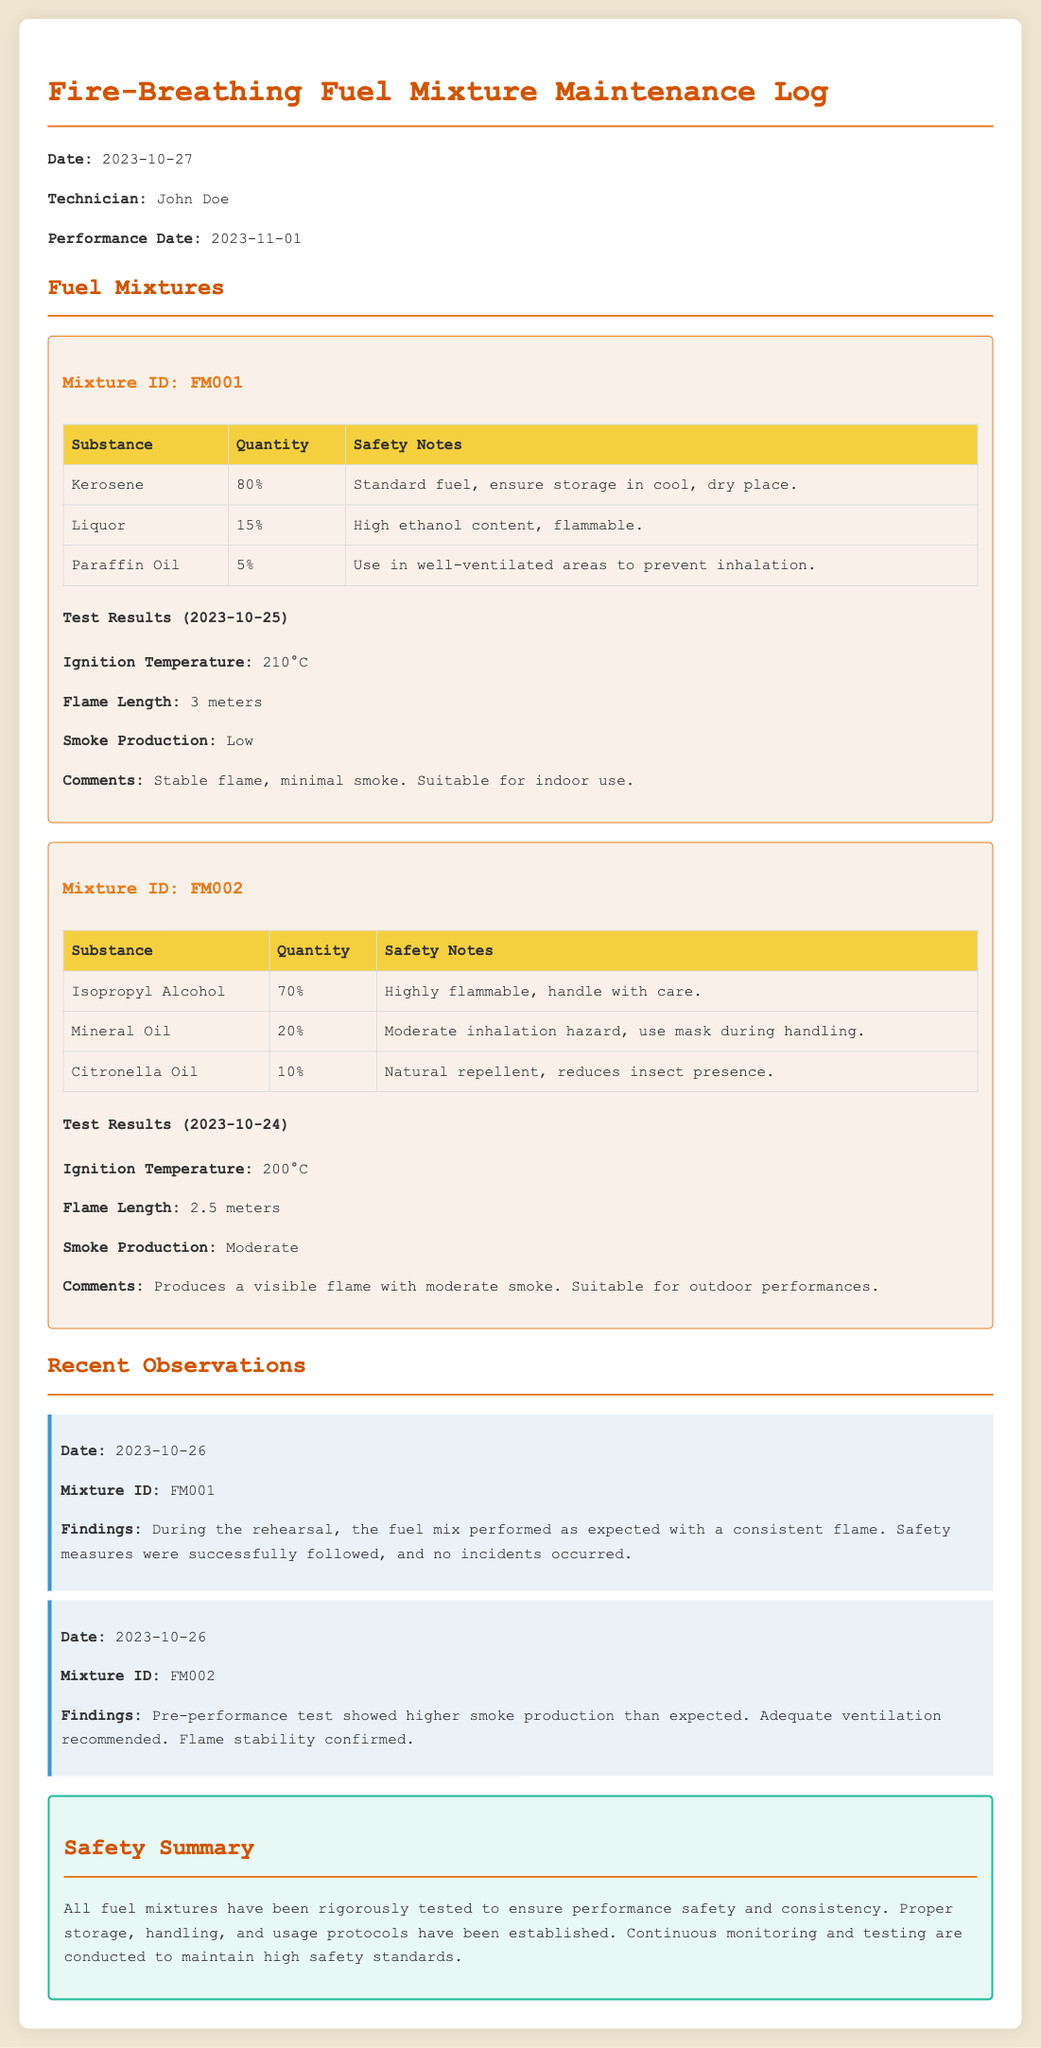What is the date of the maintenance log? The date of the maintenance log is explicitly stated at the beginning of the document.
Answer: 2023-10-27 Who is the technician responsible for the fuel mixture log? The name of the technician is mentioned in the introductory section of the document.
Answer: John Doe What is the mixture ID for the first fuel mixture? Each mixture is clearly labeled with an ID in the document.
Answer: FM001 What is the flame length for Mixture ID FM002? The flame length for each mixture is detailed in the test results section.
Answer: 2.5 meters What safety note is provided for Kerosene in Mixture ID FM001? The safety notes for each substance are included in the fuel mixtures section.
Answer: Standard fuel, ensure storage in cool, dry place What were the findings during the rehearsal for Mixture ID FM001? Observations provide specific insights related to each mixture's performance.
Answer: The fuel mix performed as expected with a consistent flame What was the ignition temperature of Mixture ID FM001? The ignition temperatures are listed under the test results for each mixture.
Answer: 210°C What is recommended for Mixture ID FM002 based on the observations? The findings suggest necessary precautions based on the performance of the mixtures.
Answer: Adequate ventilation recommended 